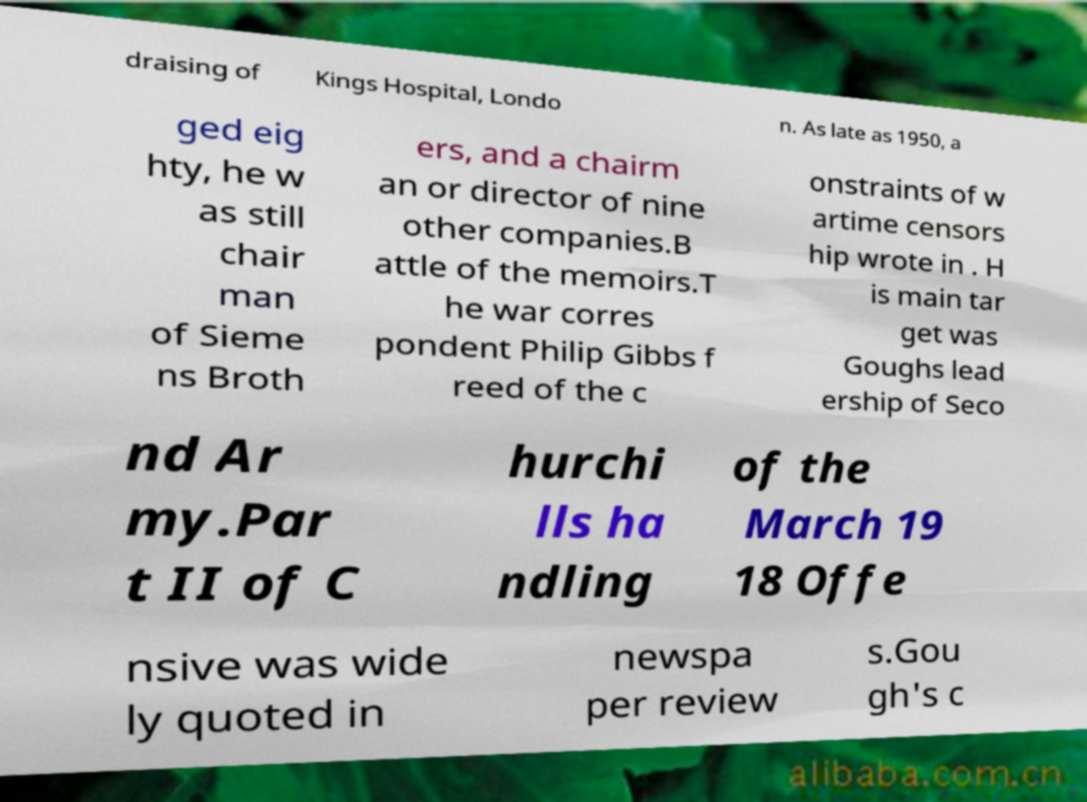Can you accurately transcribe the text from the provided image for me? draising of Kings Hospital, Londo n. As late as 1950, a ged eig hty, he w as still chair man of Sieme ns Broth ers, and a chairm an or director of nine other companies.B attle of the memoirs.T he war corres pondent Philip Gibbs f reed of the c onstraints of w artime censors hip wrote in . H is main tar get was Goughs lead ership of Seco nd Ar my.Par t II of C hurchi lls ha ndling of the March 19 18 Offe nsive was wide ly quoted in newspa per review s.Gou gh's c 